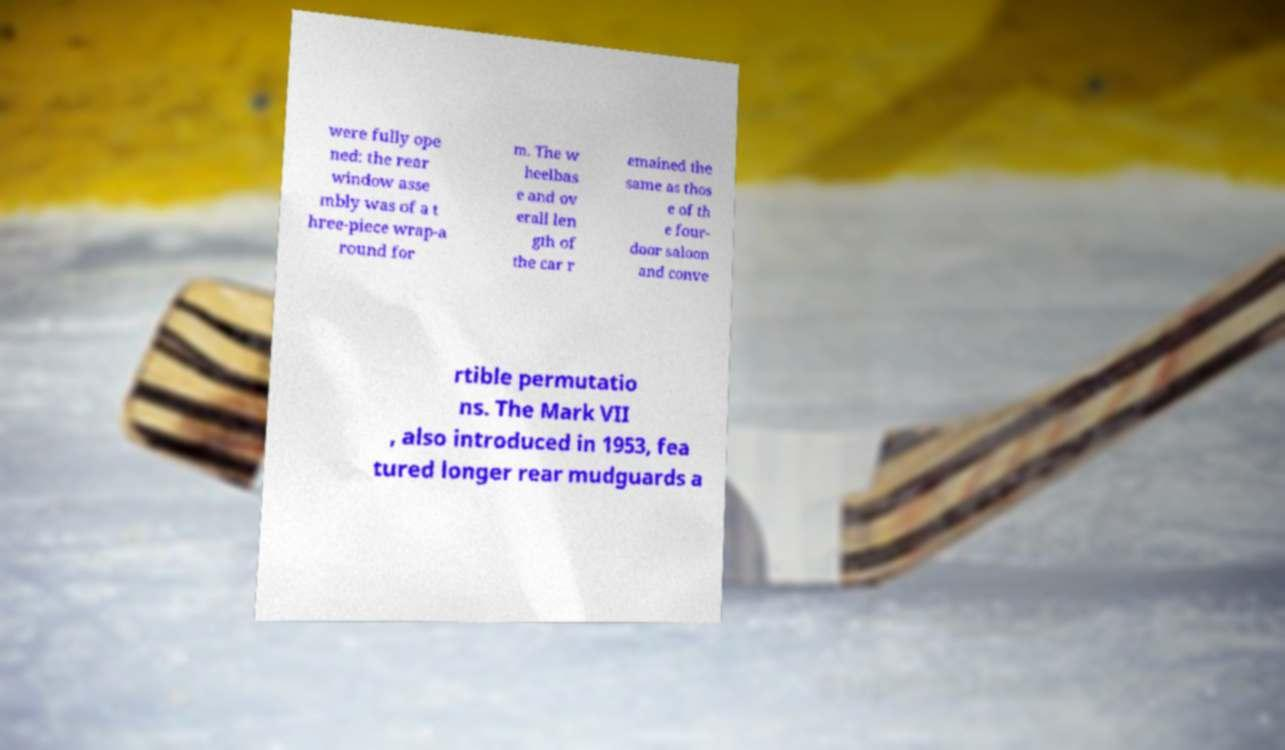Could you assist in decoding the text presented in this image and type it out clearly? were fully ope ned: the rear window asse mbly was of a t hree-piece wrap-a round for m. The w heelbas e and ov erall len gth of the car r emained the same as thos e of th e four- door saloon and conve rtible permutatio ns. The Mark VII , also introduced in 1953, fea tured longer rear mudguards a 